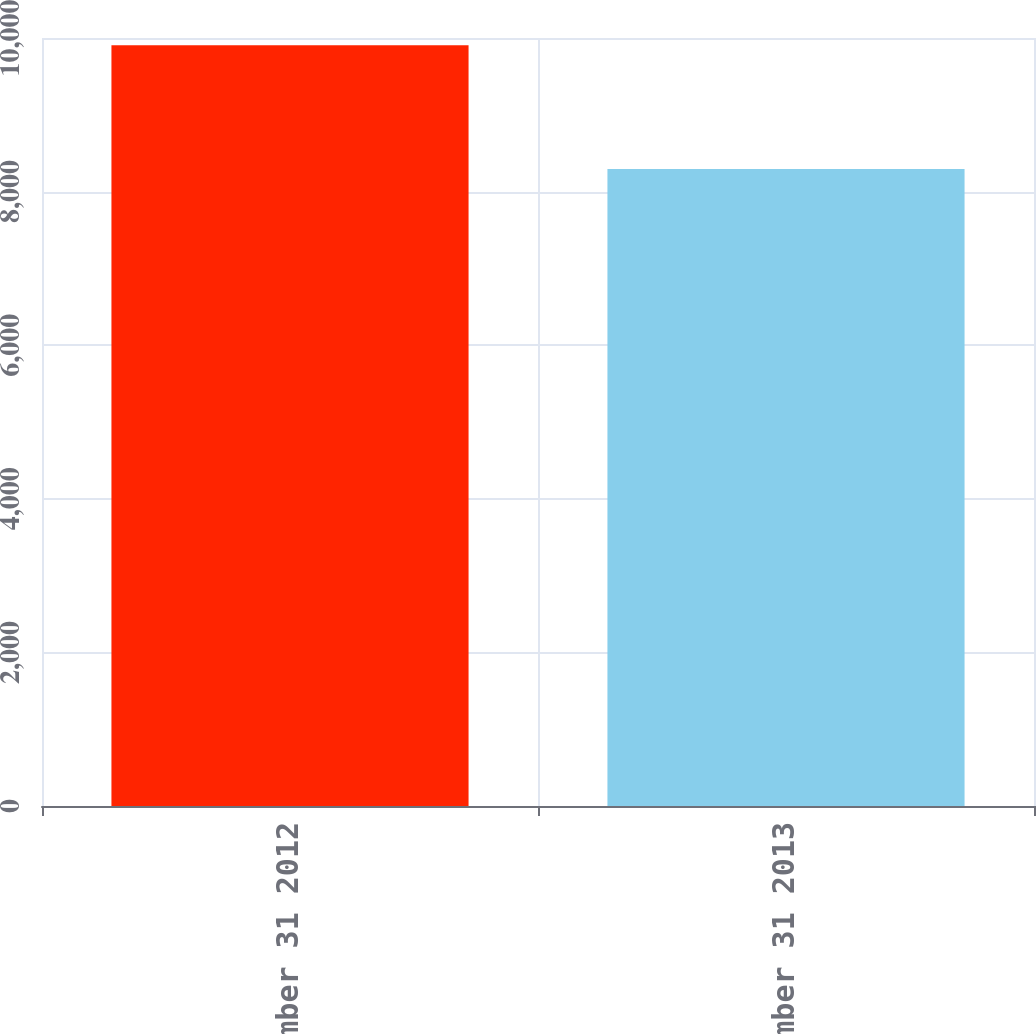Convert chart to OTSL. <chart><loc_0><loc_0><loc_500><loc_500><bar_chart><fcel>December 31 2012<fcel>December 31 2013<nl><fcel>9906<fcel>8295<nl></chart> 